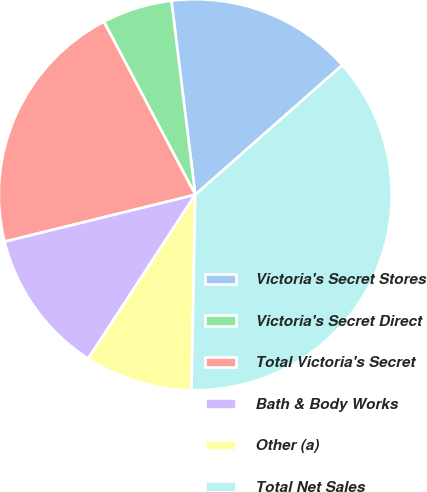Convert chart. <chart><loc_0><loc_0><loc_500><loc_500><pie_chart><fcel>Victoria's Secret Stores<fcel>Victoria's Secret Direct<fcel>Total Victoria's Secret<fcel>Bath & Body Works<fcel>Other (a)<fcel>Total Net Sales<nl><fcel>15.4%<fcel>5.76%<fcel>21.16%<fcel>11.97%<fcel>8.87%<fcel>36.85%<nl></chart> 